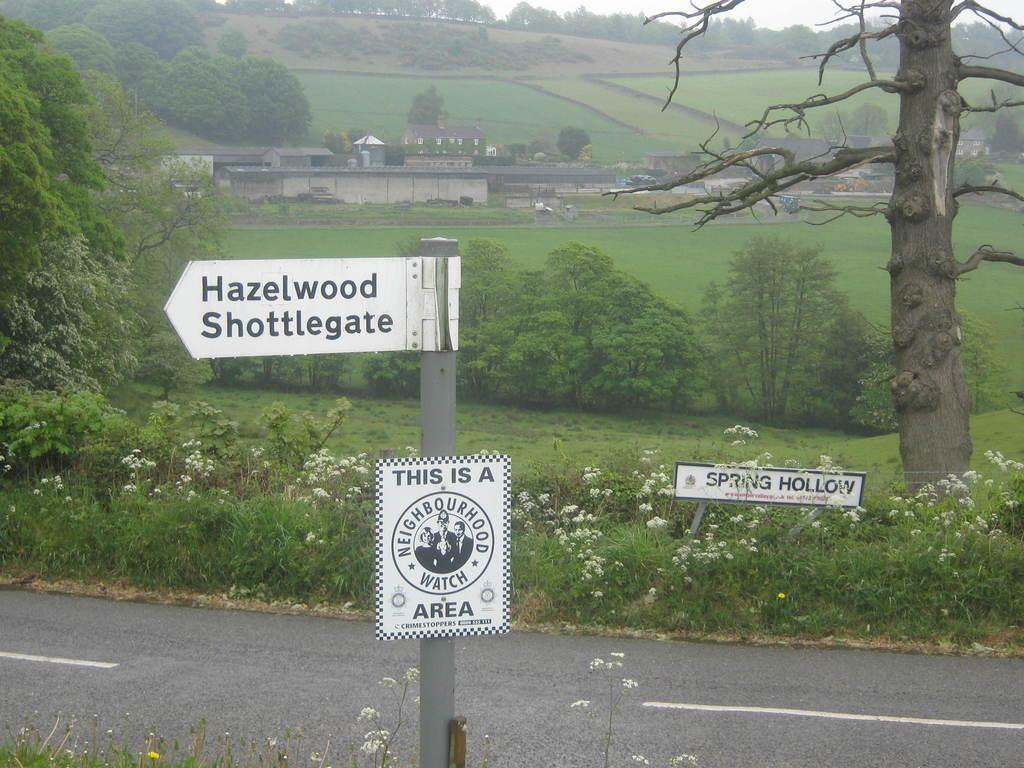What is placed on the ground in the image? There are hoardings on the ground in the image. What type of vegetation is present on the ground? The ground is covered with grass. What can be seen in the background of the image? There are trees visible in the image. What type of structures are present in the image? There are buildings in the image. What color is the daughter's dress in the image? There is no daughter present in the image, so it is not possible to answer that question. 